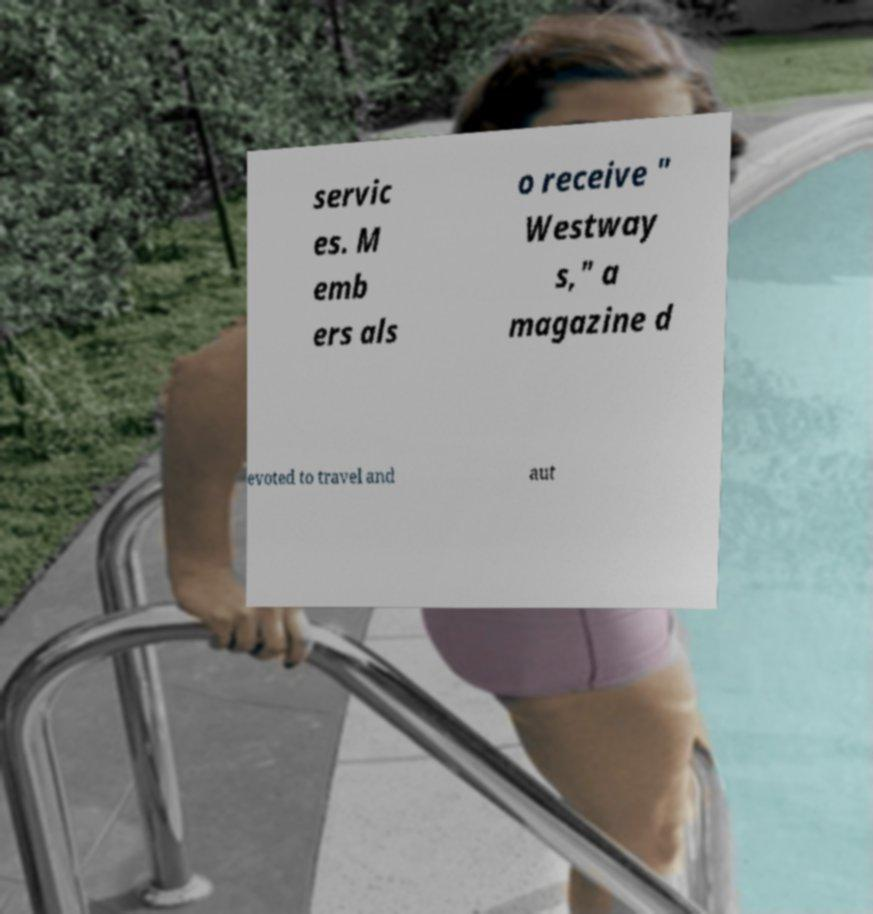What messages or text are displayed in this image? I need them in a readable, typed format. servic es. M emb ers als o receive " Westway s," a magazine d evoted to travel and aut 